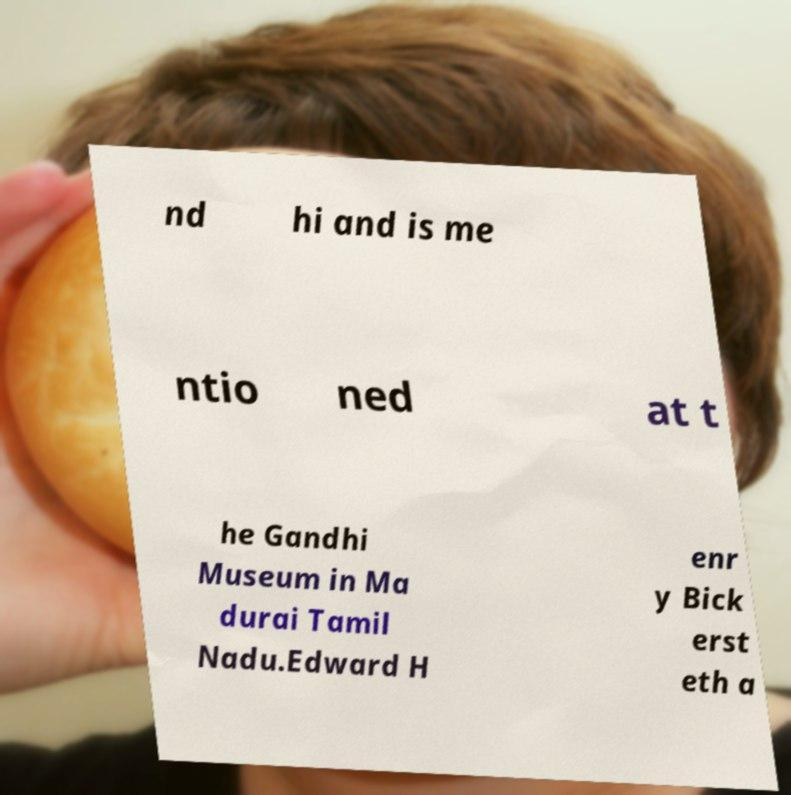Could you extract and type out the text from this image? nd hi and is me ntio ned at t he Gandhi Museum in Ma durai Tamil Nadu.Edward H enr y Bick erst eth a 